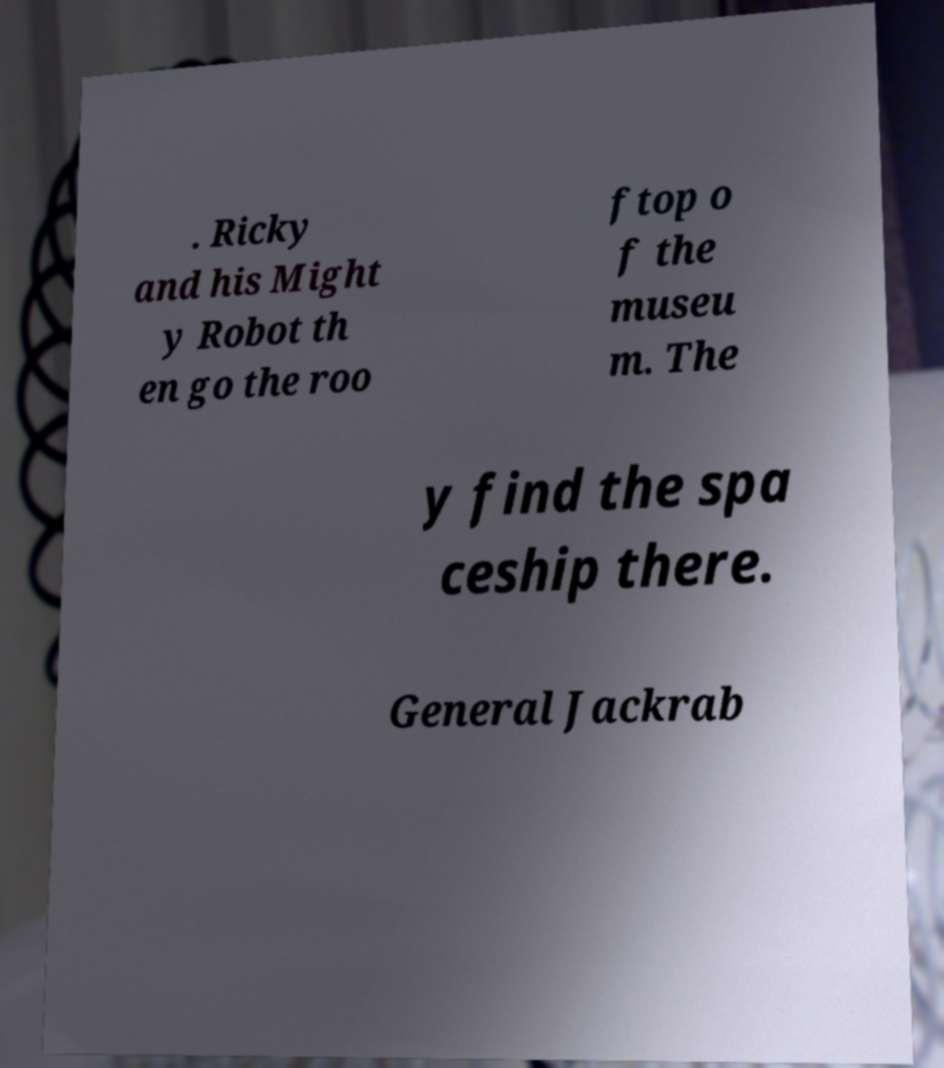I need the written content from this picture converted into text. Can you do that? . Ricky and his Might y Robot th en go the roo ftop o f the museu m. The y find the spa ceship there. General Jackrab 